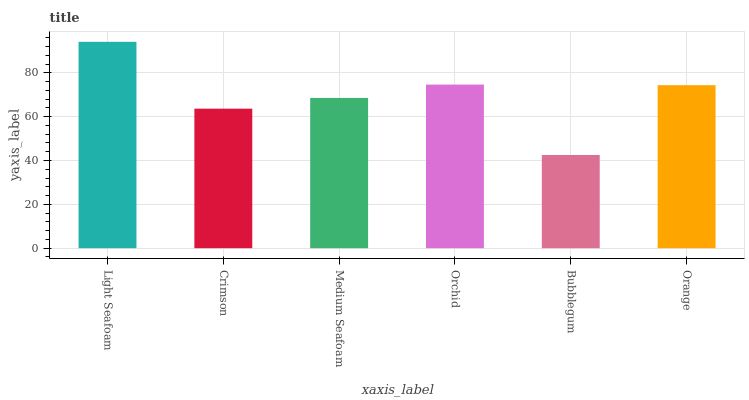Is Bubblegum the minimum?
Answer yes or no. Yes. Is Light Seafoam the maximum?
Answer yes or no. Yes. Is Crimson the minimum?
Answer yes or no. No. Is Crimson the maximum?
Answer yes or no. No. Is Light Seafoam greater than Crimson?
Answer yes or no. Yes. Is Crimson less than Light Seafoam?
Answer yes or no. Yes. Is Crimson greater than Light Seafoam?
Answer yes or no. No. Is Light Seafoam less than Crimson?
Answer yes or no. No. Is Orange the high median?
Answer yes or no. Yes. Is Medium Seafoam the low median?
Answer yes or no. Yes. Is Medium Seafoam the high median?
Answer yes or no. No. Is Orange the low median?
Answer yes or no. No. 